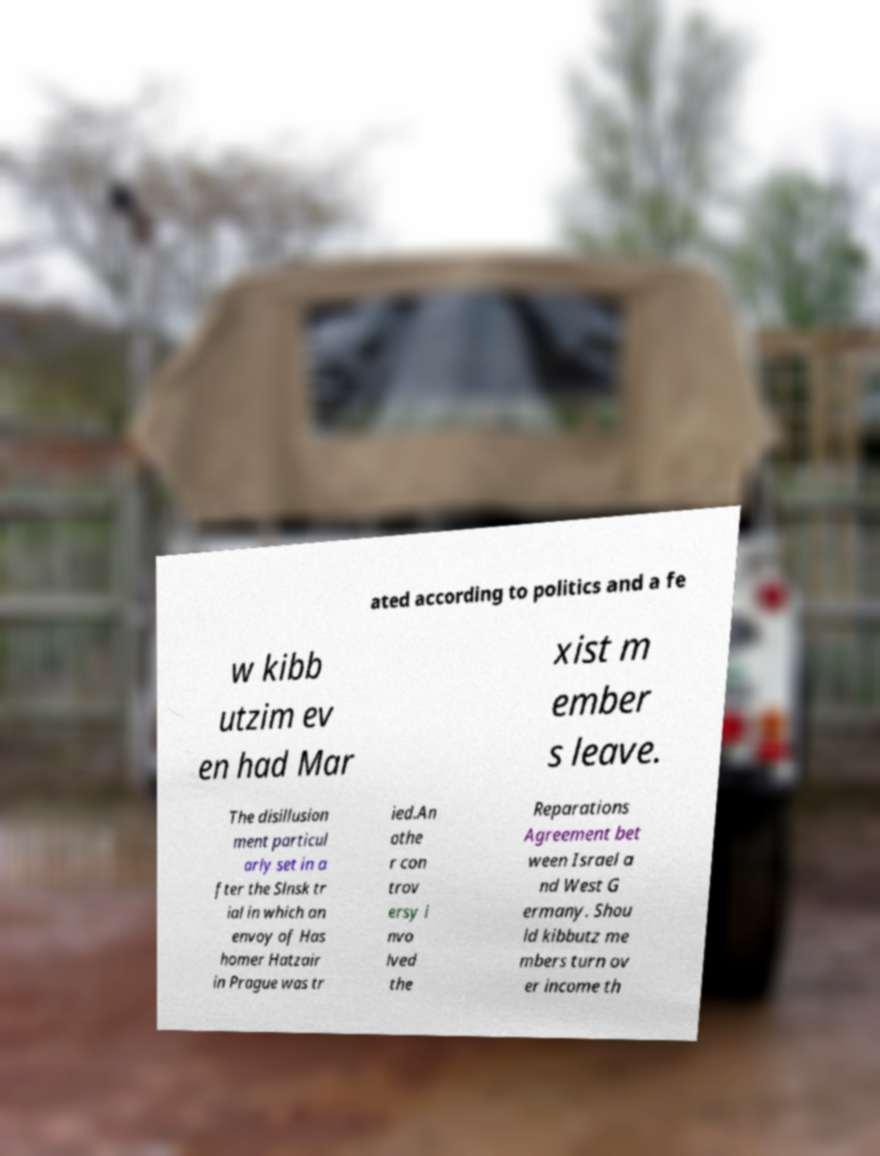Please read and relay the text visible in this image. What does it say? ated according to politics and a fe w kibb utzim ev en had Mar xist m ember s leave. The disillusion ment particul arly set in a fter the Slnsk tr ial in which an envoy of Has homer Hatzair in Prague was tr ied.An othe r con trov ersy i nvo lved the Reparations Agreement bet ween Israel a nd West G ermany. Shou ld kibbutz me mbers turn ov er income th 